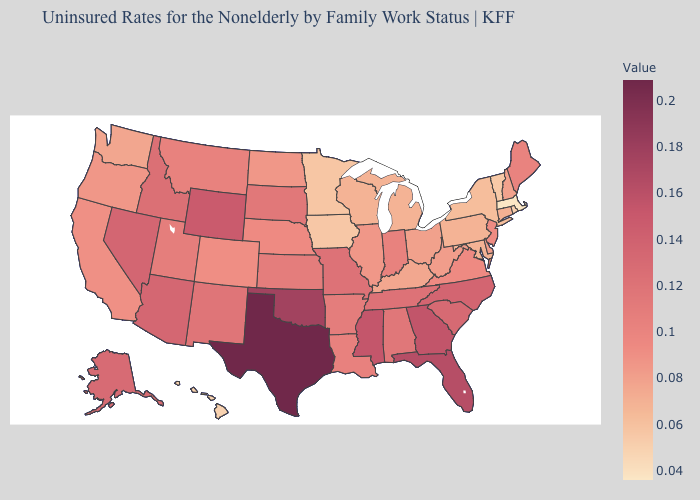Among the states that border Kentucky , which have the lowest value?
Give a very brief answer. Ohio. Which states have the highest value in the USA?
Short answer required. Texas. Among the states that border Arkansas , which have the lowest value?
Keep it brief. Louisiana. Does North Carolina have the lowest value in the South?
Short answer required. No. Does Alaska have a lower value than Virginia?
Concise answer only. No. 